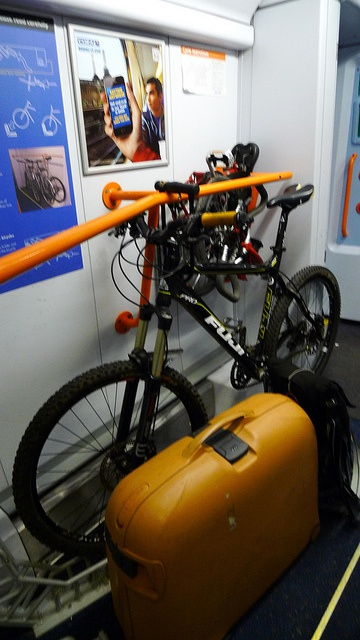Describe the objects in this image and their specific colors. I can see bicycle in black, gray, darkgray, and darkgreen tones and suitcase in black, maroon, olive, and orange tones in this image. 